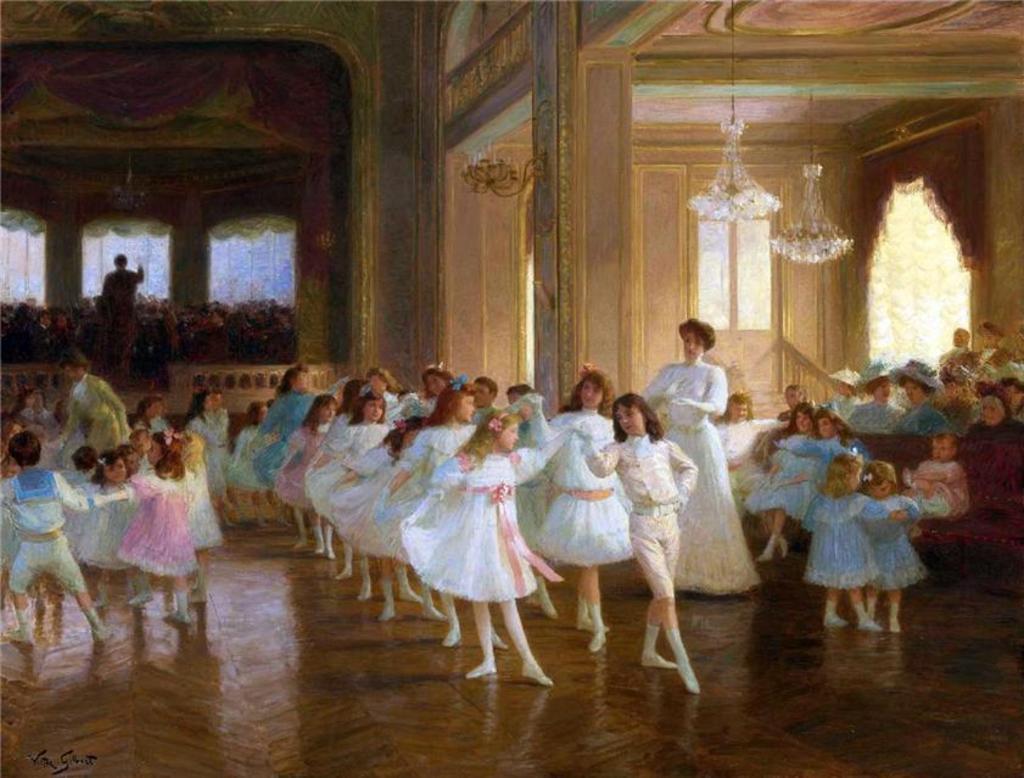Describe this image in one or two sentences. In this image on the right, there is a woman, she wears a white dress, she is standing. In the middle there are many girls, boys they are dancing. On the right there are many children, people, they are sitting. In the background there are lights, pillars, person, plants, curtains, floor. 